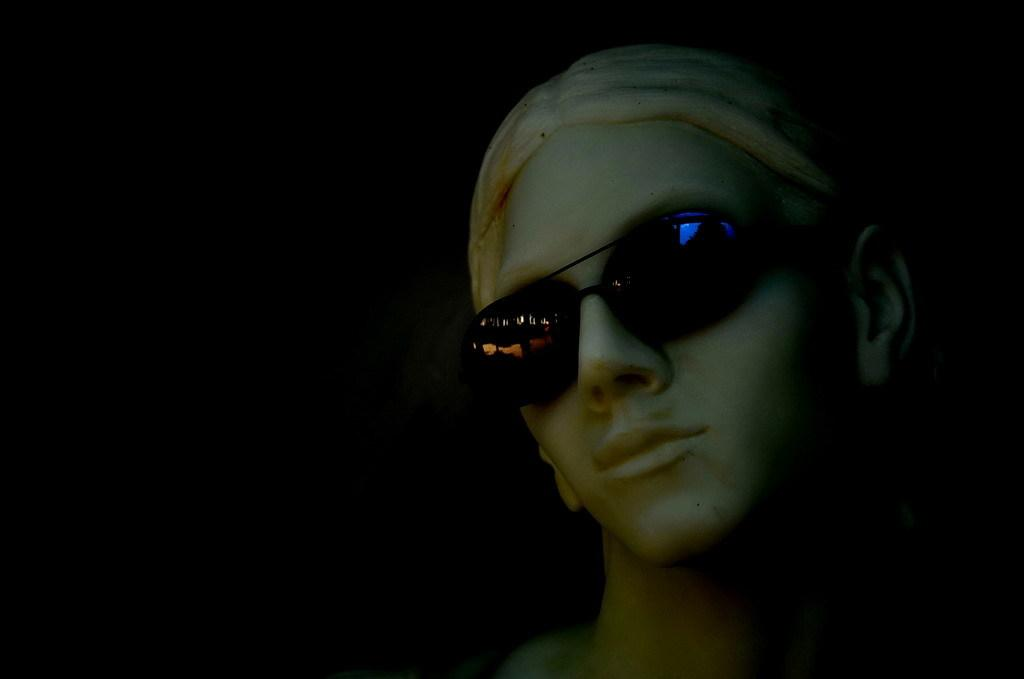What is the main subject of the image? There is a person in the image. What can be observed about the person's appearance? The person is wearing spectacles. How would you describe the background of the image? The background of the image has a dark view. What type of roof can be seen on the person in the image? There is no roof present in the image; it features a person wearing spectacles. What role does the fireman play in the image? There is no fireman present in the image; it only features a person wearing spectacles. 